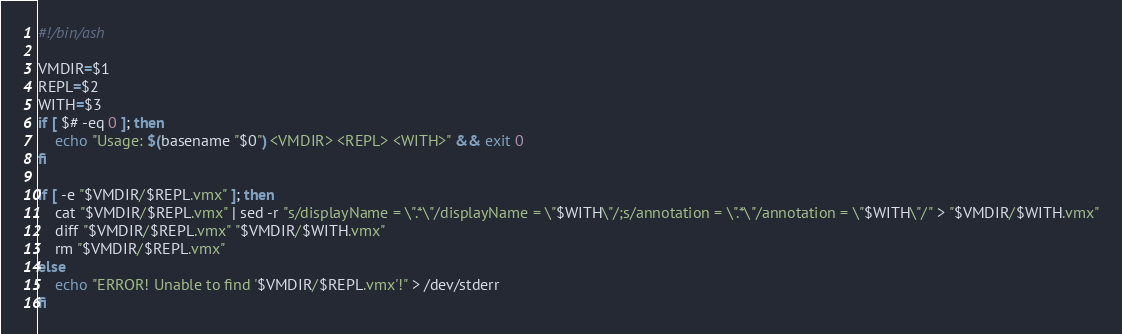Convert code to text. <code><loc_0><loc_0><loc_500><loc_500><_Bash_>#!/bin/ash

VMDIR=$1
REPL=$2
WITH=$3
if [ $# -eq 0 ]; then
	echo "Usage: $(basename "$0") <VMDIR> <REPL> <WITH>" && exit 0
fi

if [ -e "$VMDIR/$REPL.vmx" ]; then
	cat "$VMDIR/$REPL.vmx" | sed -r "s/displayName = \".*\"/displayName = \"$WITH\"/;s/annotation = \".*\"/annotation = \"$WITH\"/" > "$VMDIR/$WITH.vmx"
	diff "$VMDIR/$REPL.vmx" "$VMDIR/$WITH.vmx"
	rm "$VMDIR/$REPL.vmx"
else
	echo "ERROR! Unable to find '$VMDIR/$REPL.vmx'!" > /dev/stderr
fi
</code> 